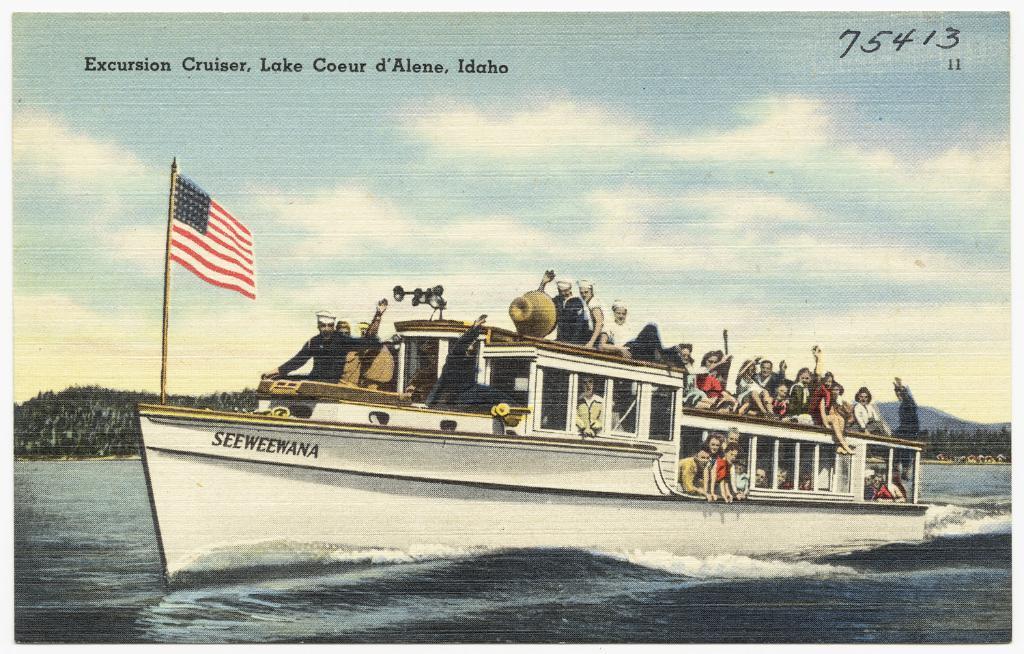Could you give a brief overview of what you see in this image? In this image we can see the poster of a boat with the people and the boat is present on the surface of the water. We can also see the flag, trees, hill and also the sky with the clouds. We can also see the text and also numbers at the top. 